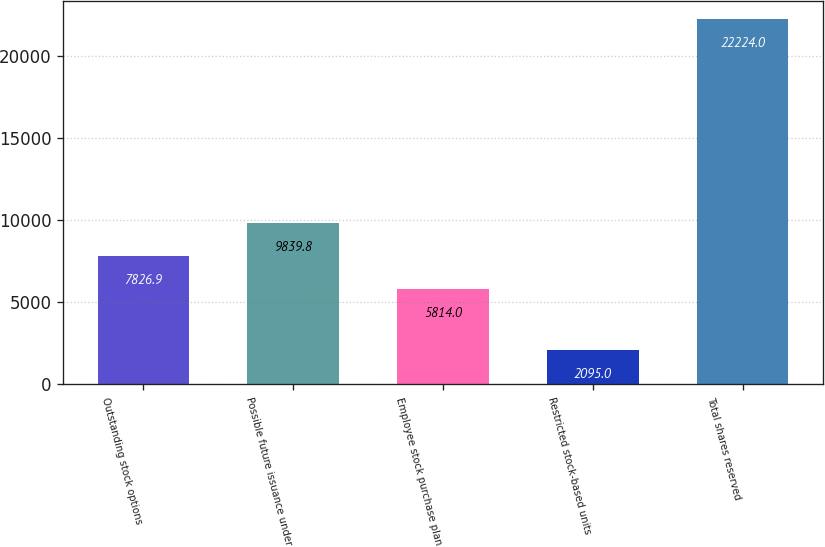Convert chart. <chart><loc_0><loc_0><loc_500><loc_500><bar_chart><fcel>Outstanding stock options<fcel>Possible future issuance under<fcel>Employee stock purchase plan<fcel>Restricted stock-based units<fcel>Total shares reserved<nl><fcel>7826.9<fcel>9839.8<fcel>5814<fcel>2095<fcel>22224<nl></chart> 